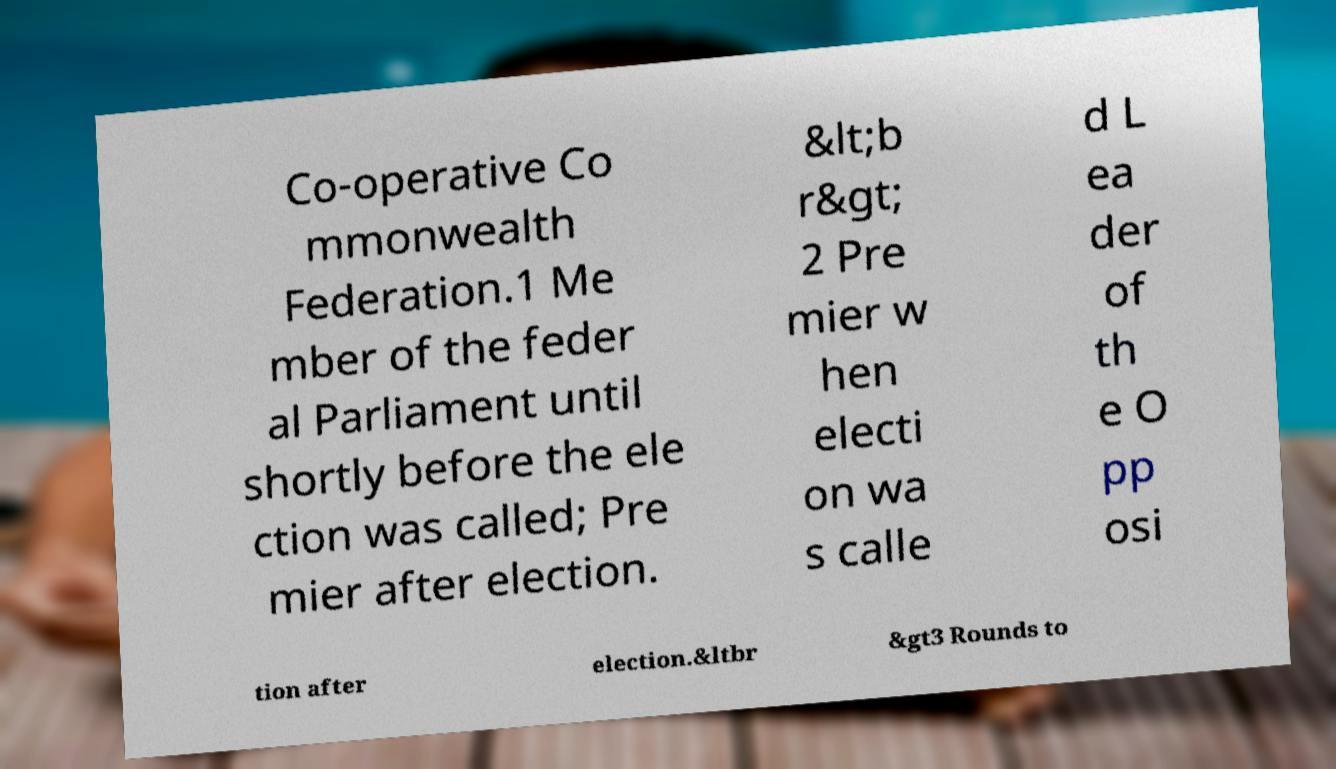Please identify and transcribe the text found in this image. Co-operative Co mmonwealth Federation.1 Me mber of the feder al Parliament until shortly before the ele ction was called; Pre mier after election. &lt;b r&gt; 2 Pre mier w hen electi on wa s calle d L ea der of th e O pp osi tion after election.&ltbr &gt3 Rounds to 